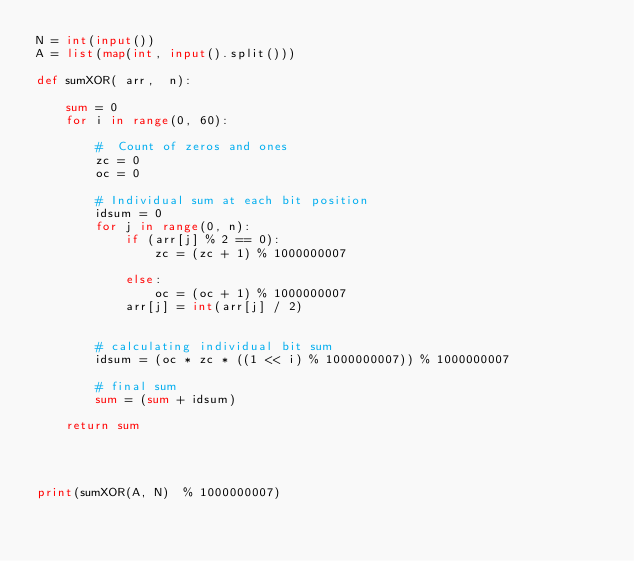Convert code to text. <code><loc_0><loc_0><loc_500><loc_500><_Python_>N = int(input())
A = list(map(int, input().split())) 

def sumXOR( arr,  n): 
      
    sum = 0
    for i in range(0, 60): 
  
        #  Count of zeros and ones 
        zc = 0
        oc = 0
           
        # Individual sum at each bit position 
        idsum = 0
        for j in range(0, n): 
            if (arr[j] % 2 == 0): 
                zc = (zc + 1) % 1000000007
                  
            else: 
                oc = (oc + 1) % 1000000007
            arr[j] = int(arr[j] / 2) 
          
           
        # calculating individual bit sum  
        idsum = (oc * zc * ((1 << i) % 1000000007)) % 1000000007
   
        # final sum     
        sum = (sum + idsum)
      
    return sum
  
  
  
  
print(sumXOR(A, N)  % 1000000007)</code> 